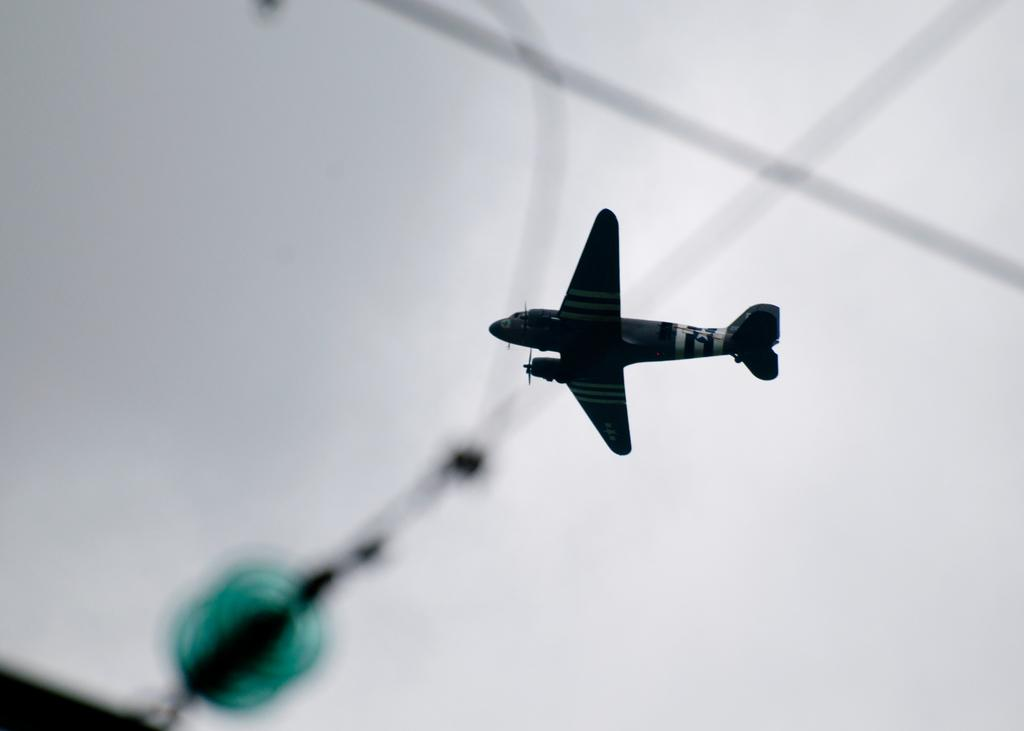What is the main subject of the image? The main subject of the image is an airplane. What is the airplane doing in the image? The airplane is flying in the sky. Are there any other objects or features visible in the image? Yes, there are cables visible in the image. How many balls can be seen rolling down the hill in the image? There are no balls or hills present in the image; it features an airplane flying in the sky with visible cables. 